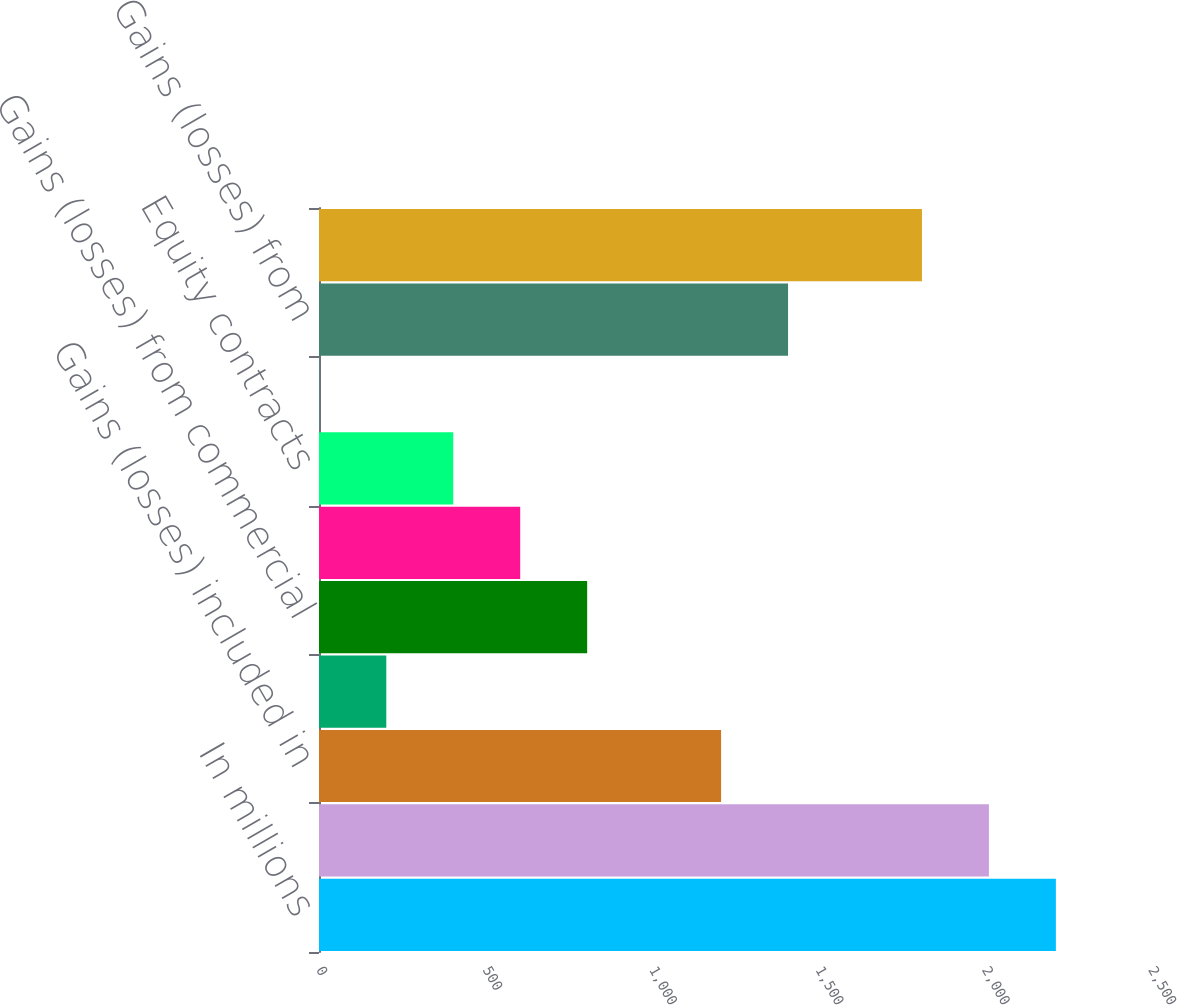<chart> <loc_0><loc_0><loc_500><loc_500><bar_chart><fcel>In millions<fcel>Interest rate contracts<fcel>Gains (losses) included in<fcel>Credit contracts (c)<fcel>Gains (losses) from commercial<fcel>Foreign exchange contracts<fcel>Equity contracts<fcel>Credit contracts<fcel>Gains (losses) from<fcel>Other contracts (d)<nl><fcel>2214.2<fcel>2013<fcel>1208.2<fcel>202.2<fcel>805.8<fcel>604.6<fcel>403.4<fcel>1<fcel>1409.4<fcel>1811.8<nl></chart> 